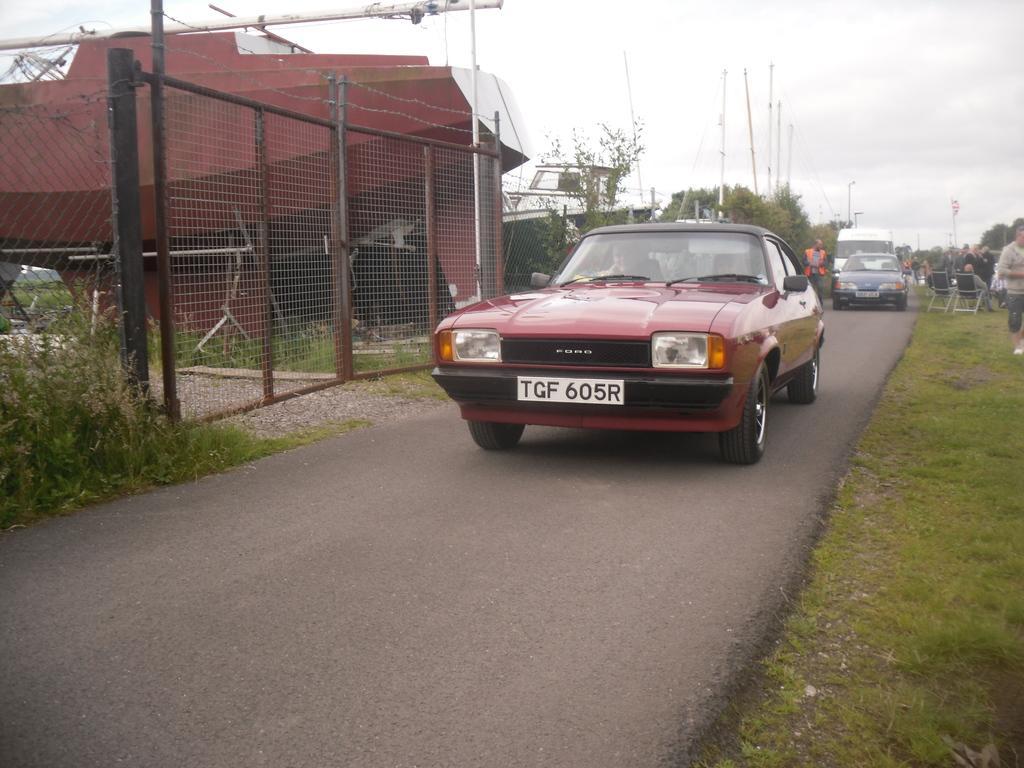How would you summarize this image in a sentence or two? In this image, there are vehicles on the road. On the right side of the image, I can see few people standing, few people sitting on the chairs and I can see grass. On the left side of the image, there are plants. There are trees, poles, gate, boat and an architecture. In the background, there is the sky. 